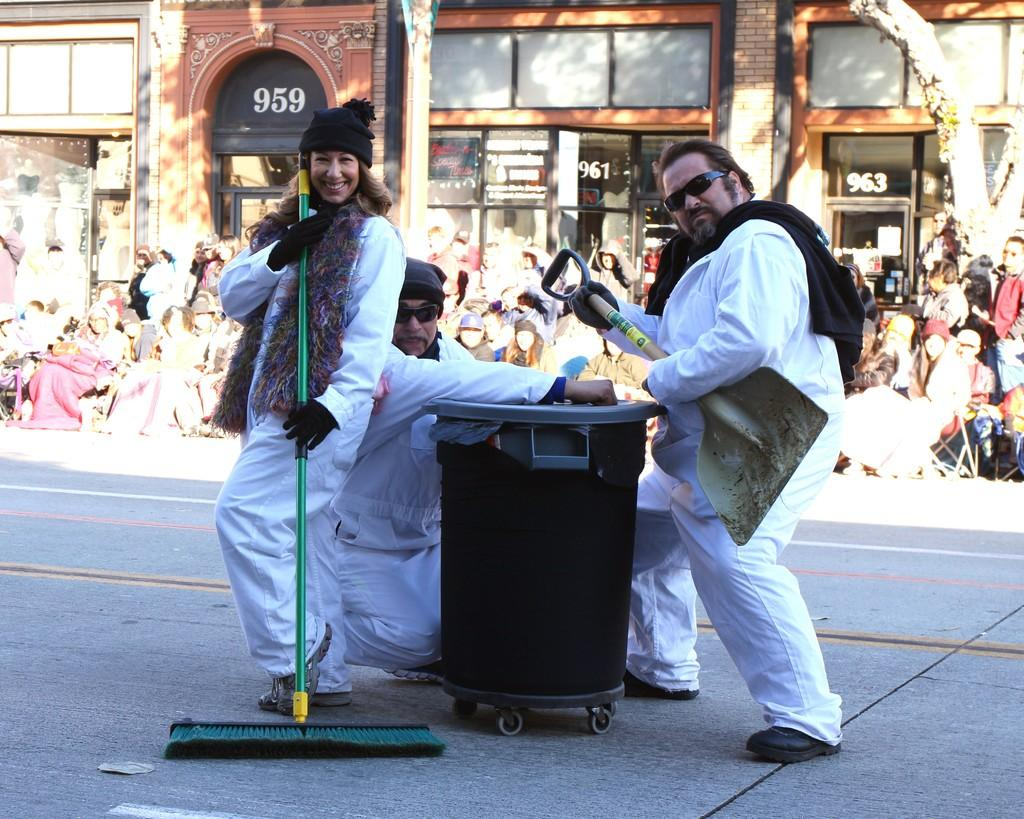<image>
Create a compact narrative representing the image presented. People pretend to play yard tools in front of building number 959. 